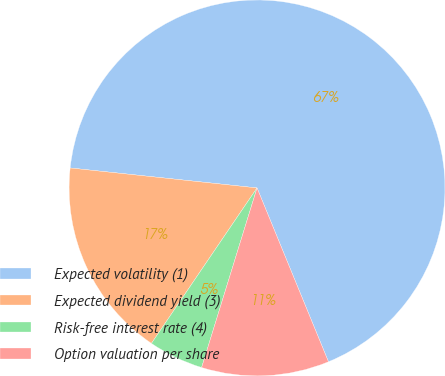Convert chart to OTSL. <chart><loc_0><loc_0><loc_500><loc_500><pie_chart><fcel>Expected volatility (1)<fcel>Expected dividend yield (3)<fcel>Risk-free interest rate (4)<fcel>Option valuation per share<nl><fcel>67.1%<fcel>17.2%<fcel>4.73%<fcel>10.97%<nl></chart> 